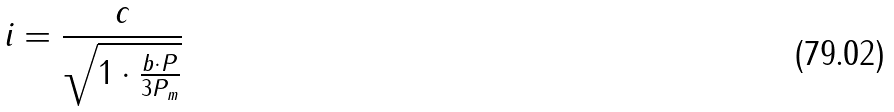<formula> <loc_0><loc_0><loc_500><loc_500>i = \frac { c } { \sqrt { 1 \cdot \frac { b \cdot P } { 3 P _ { m } } } }</formula> 